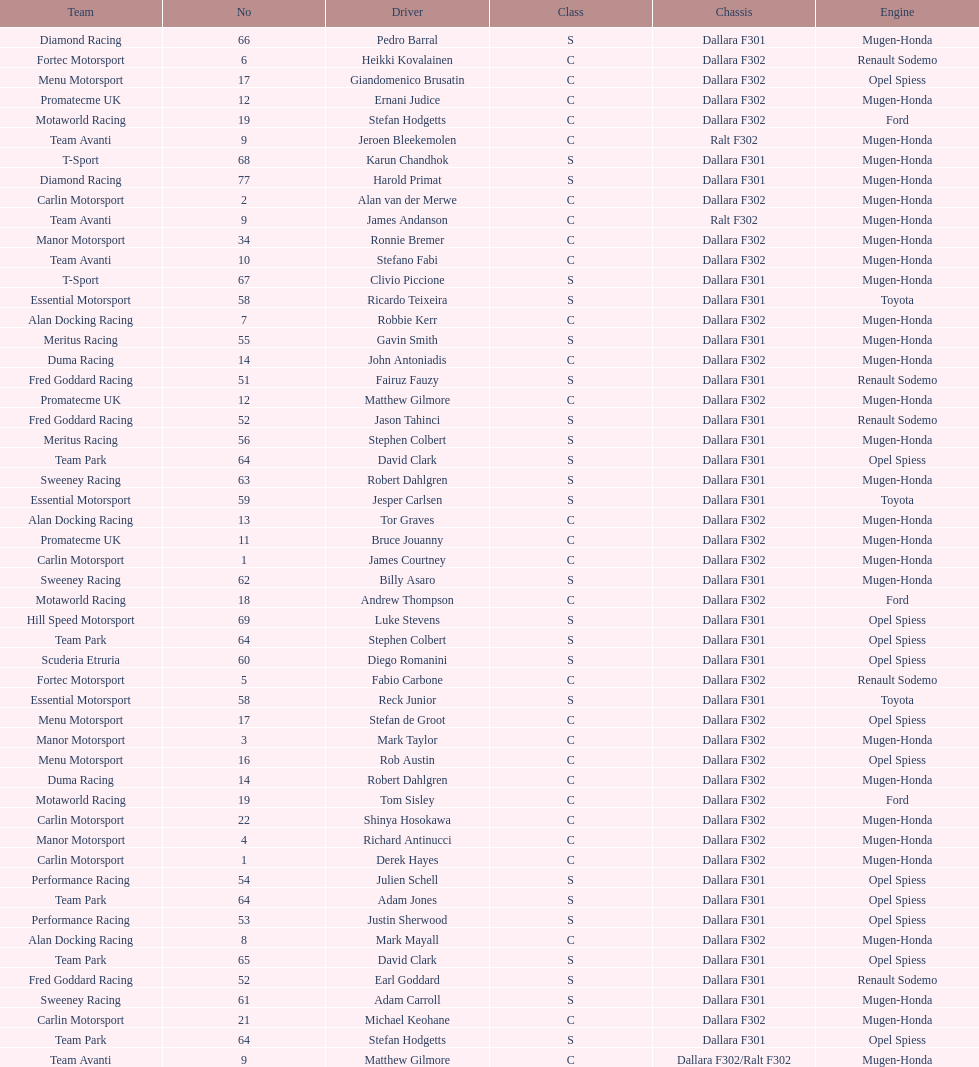How many teams had at least two drivers this season? 17. 